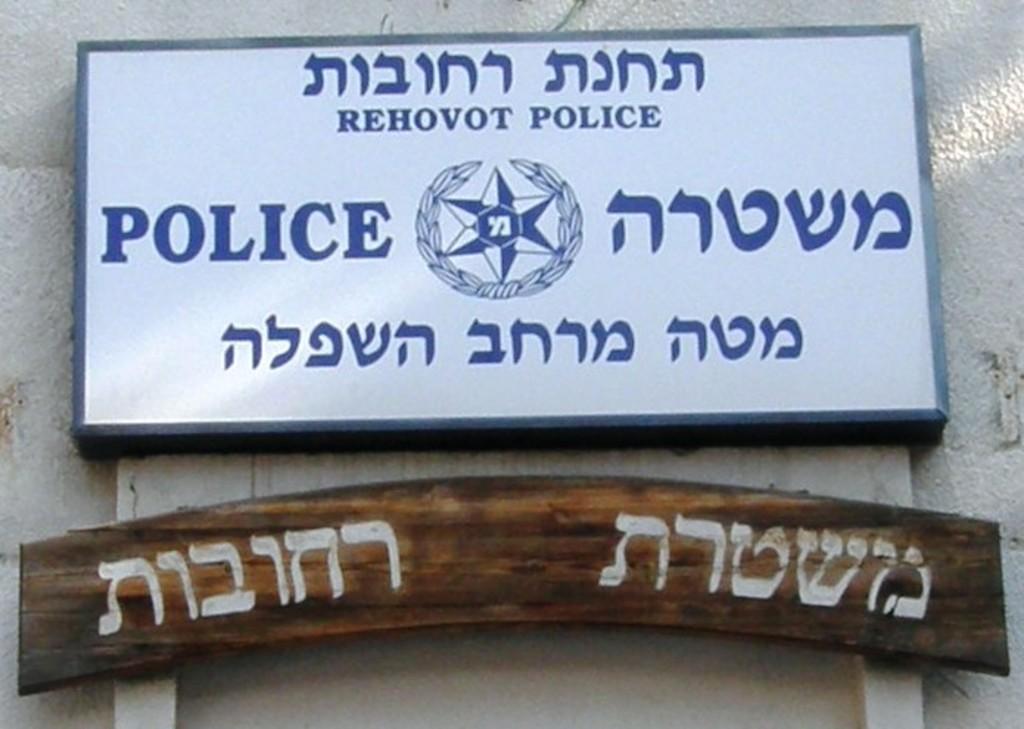What is this sign for?
Your answer should be compact. Police. What city is this sign in?
Your response must be concise. Rehovot. 